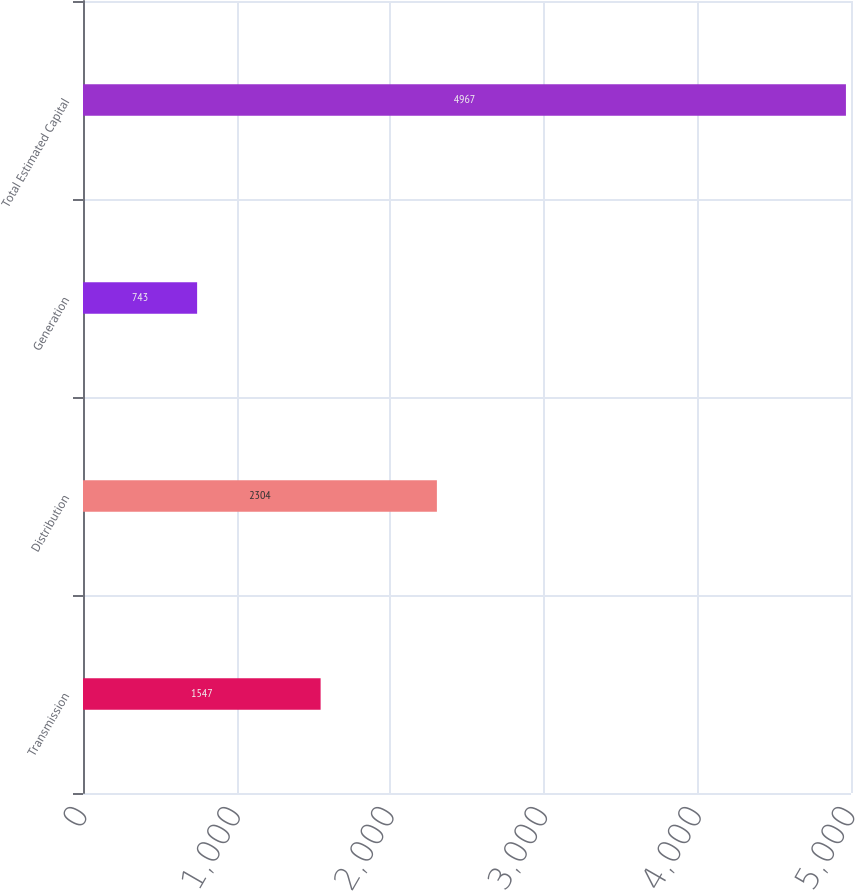Convert chart to OTSL. <chart><loc_0><loc_0><loc_500><loc_500><bar_chart><fcel>Transmission<fcel>Distribution<fcel>Generation<fcel>Total Estimated Capital<nl><fcel>1547<fcel>2304<fcel>743<fcel>4967<nl></chart> 